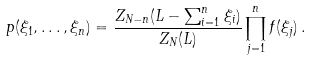<formula> <loc_0><loc_0><loc_500><loc_500>p ( \xi _ { 1 } , \dots , \xi _ { n } ) = \frac { Z _ { N - n } ( L - \sum _ { i = 1 } ^ { n } \xi _ { i } ) } { Z _ { N } ( L ) } \prod _ { j = 1 } ^ { n } f ( \xi _ { j } ) \, .</formula> 